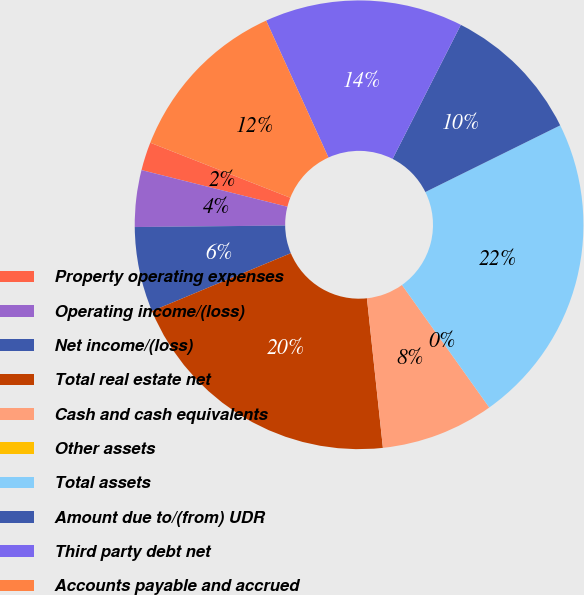Convert chart to OTSL. <chart><loc_0><loc_0><loc_500><loc_500><pie_chart><fcel>Property operating expenses<fcel>Operating income/(loss)<fcel>Net income/(loss)<fcel>Total real estate net<fcel>Cash and cash equivalents<fcel>Other assets<fcel>Total assets<fcel>Amount due to/(from) UDR<fcel>Third party debt net<fcel>Accounts payable and accrued<nl><fcel>2.04%<fcel>4.08%<fcel>6.12%<fcel>20.41%<fcel>8.16%<fcel>0.0%<fcel>22.45%<fcel>10.2%<fcel>14.29%<fcel>12.24%<nl></chart> 